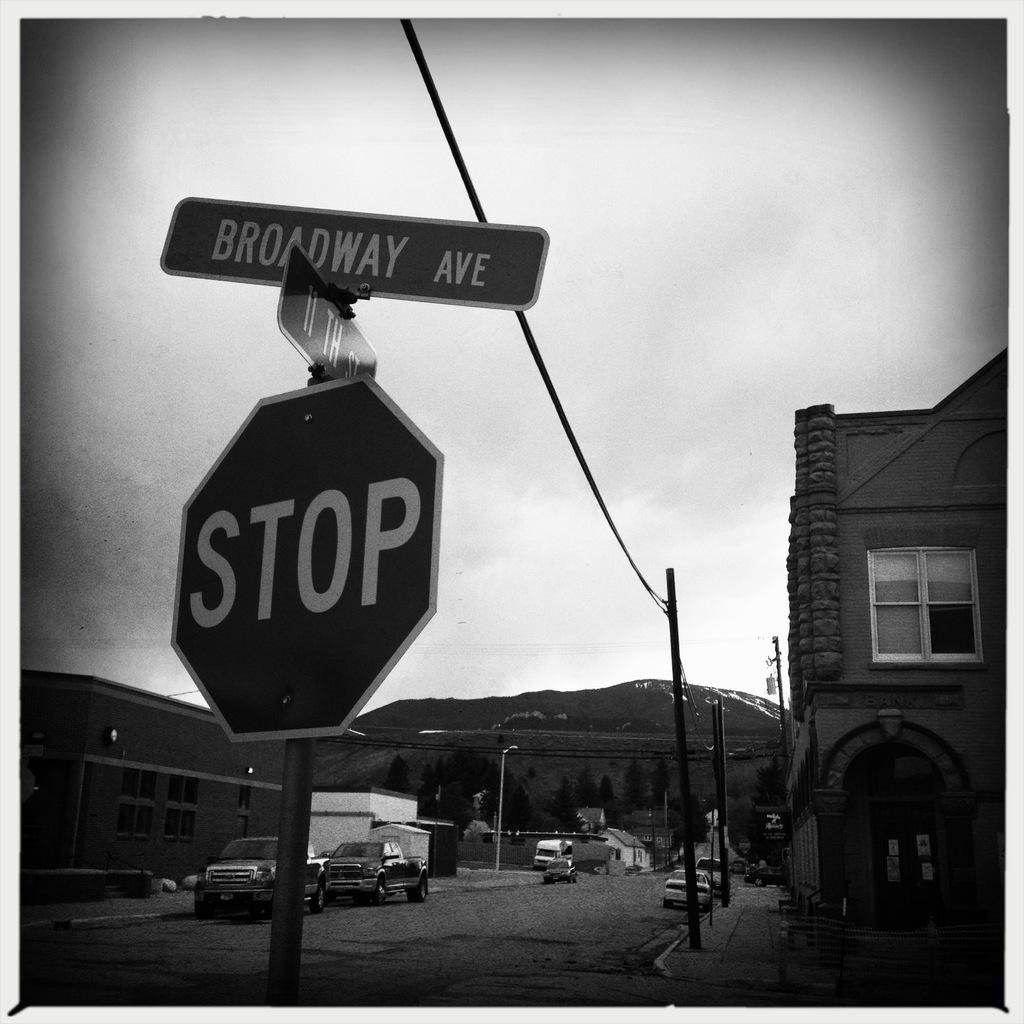What is the name on the street sign?
Your answer should be very brief. Broadway ave. What does the bottom sign want you to do?
Offer a terse response. Stop. 